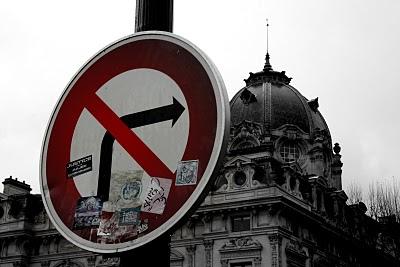What kind of traffic sign is this?
Quick response, please. No right turns. How many stickers are on the sign?
Concise answer only. 8. Which direction can you not turn?
Answer briefly. Right. 